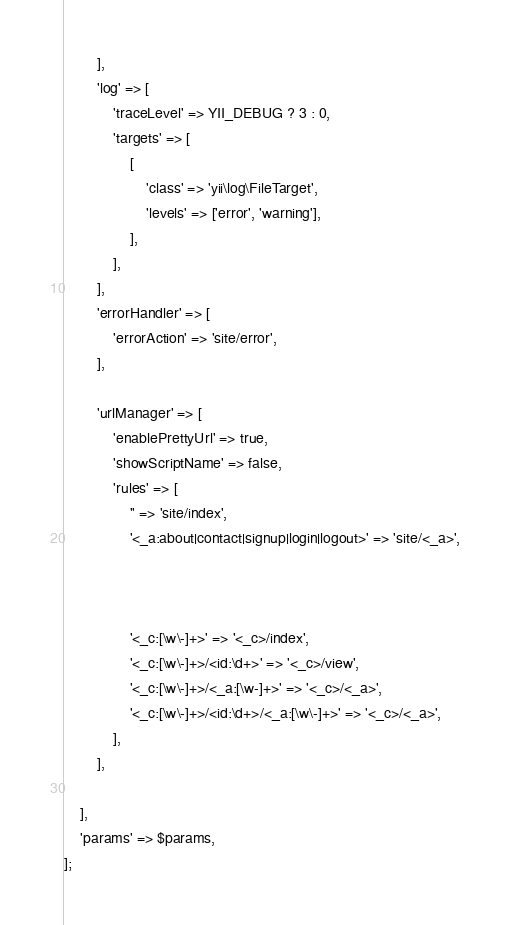<code> <loc_0><loc_0><loc_500><loc_500><_PHP_>        ],
        'log' => [
            'traceLevel' => YII_DEBUG ? 3 : 0,
            'targets' => [
                [
                    'class' => 'yii\log\FileTarget',
                    'levels' => ['error', 'warning'],
                ],
            ],
        ],
        'errorHandler' => [
            'errorAction' => 'site/error',
        ],

        'urlManager' => [
            'enablePrettyUrl' => true,
            'showScriptName' => false,
            'rules' => [
                '' => 'site/index',
                '<_a:about|contact|signup|login|logout>' => 'site/<_a>',



                '<_c:[\w\-]+>' => '<_c>/index',
                '<_c:[\w\-]+>/<id:\d+>' => '<_c>/view',
                '<_c:[\w\-]+>/<_a:[\w-]+>' => '<_c>/<_a>',
                '<_c:[\w\-]+>/<id:\d+>/<_a:[\w\-]+>' => '<_c>/<_a>',
            ],
        ],

    ],
    'params' => $params,
];
</code> 